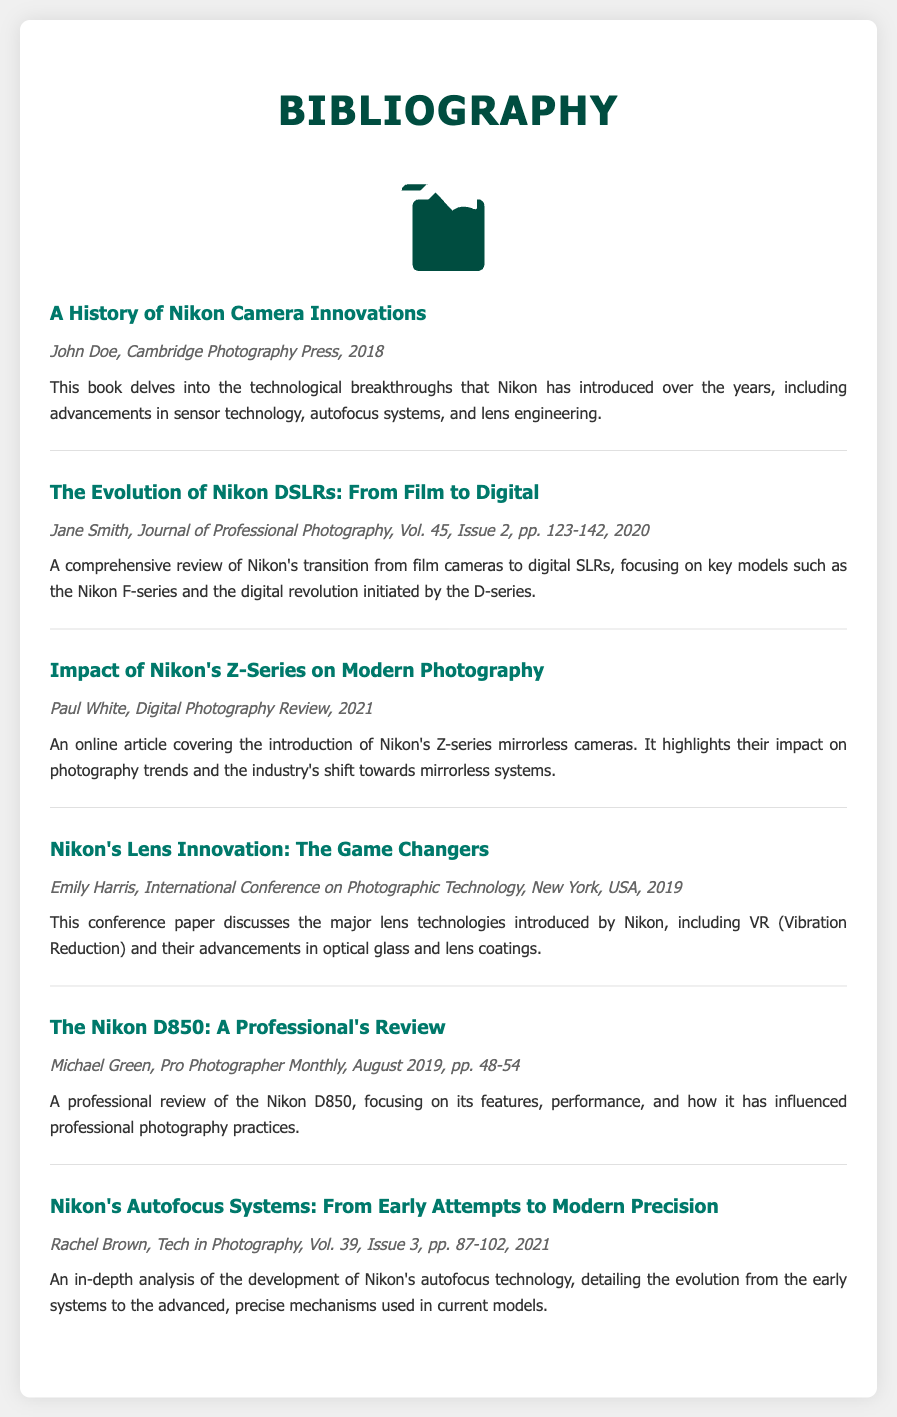What is the title of the first entry? The title of the first entry is found under the entry titled section in the bibliography.
Answer: A History of Nikon Camera Innovations Who is the author of the second entry? The author's name is listed in the entry meta section of the bibliography for the second entry.
Answer: Jane Smith In which volume and issue did the article on Nikon's autofocus systems appear? The volume and issue are indicated in the entry meta for the Nikon's Autofocus Systems entry.
Answer: Vol. 39, Issue 3 What year was the article on Nikon's Z-Series published? The publication year is noted in the entry meta for the impact of Nikon's Z-Series on modern photography.
Answer: 2021 What technology is discussed in the paper presented by Emily Harris? The technology covered can be inferred from the title and description of the entry.
Answer: Lens technologies Which Nikon model is the focus of Michael Green's review? The specific camera model being reviewed is mentioned in the title of the corresponding entry.
Answer: Nikon D850 How many entries are listed in this bibliography? The total number of entries can be counted from the visible sections in the document.
Answer: Six Who published the first entry? The publisher's name is mentioned in the entry meta section of the first entry.
Answer: Cambridge Photography Press 